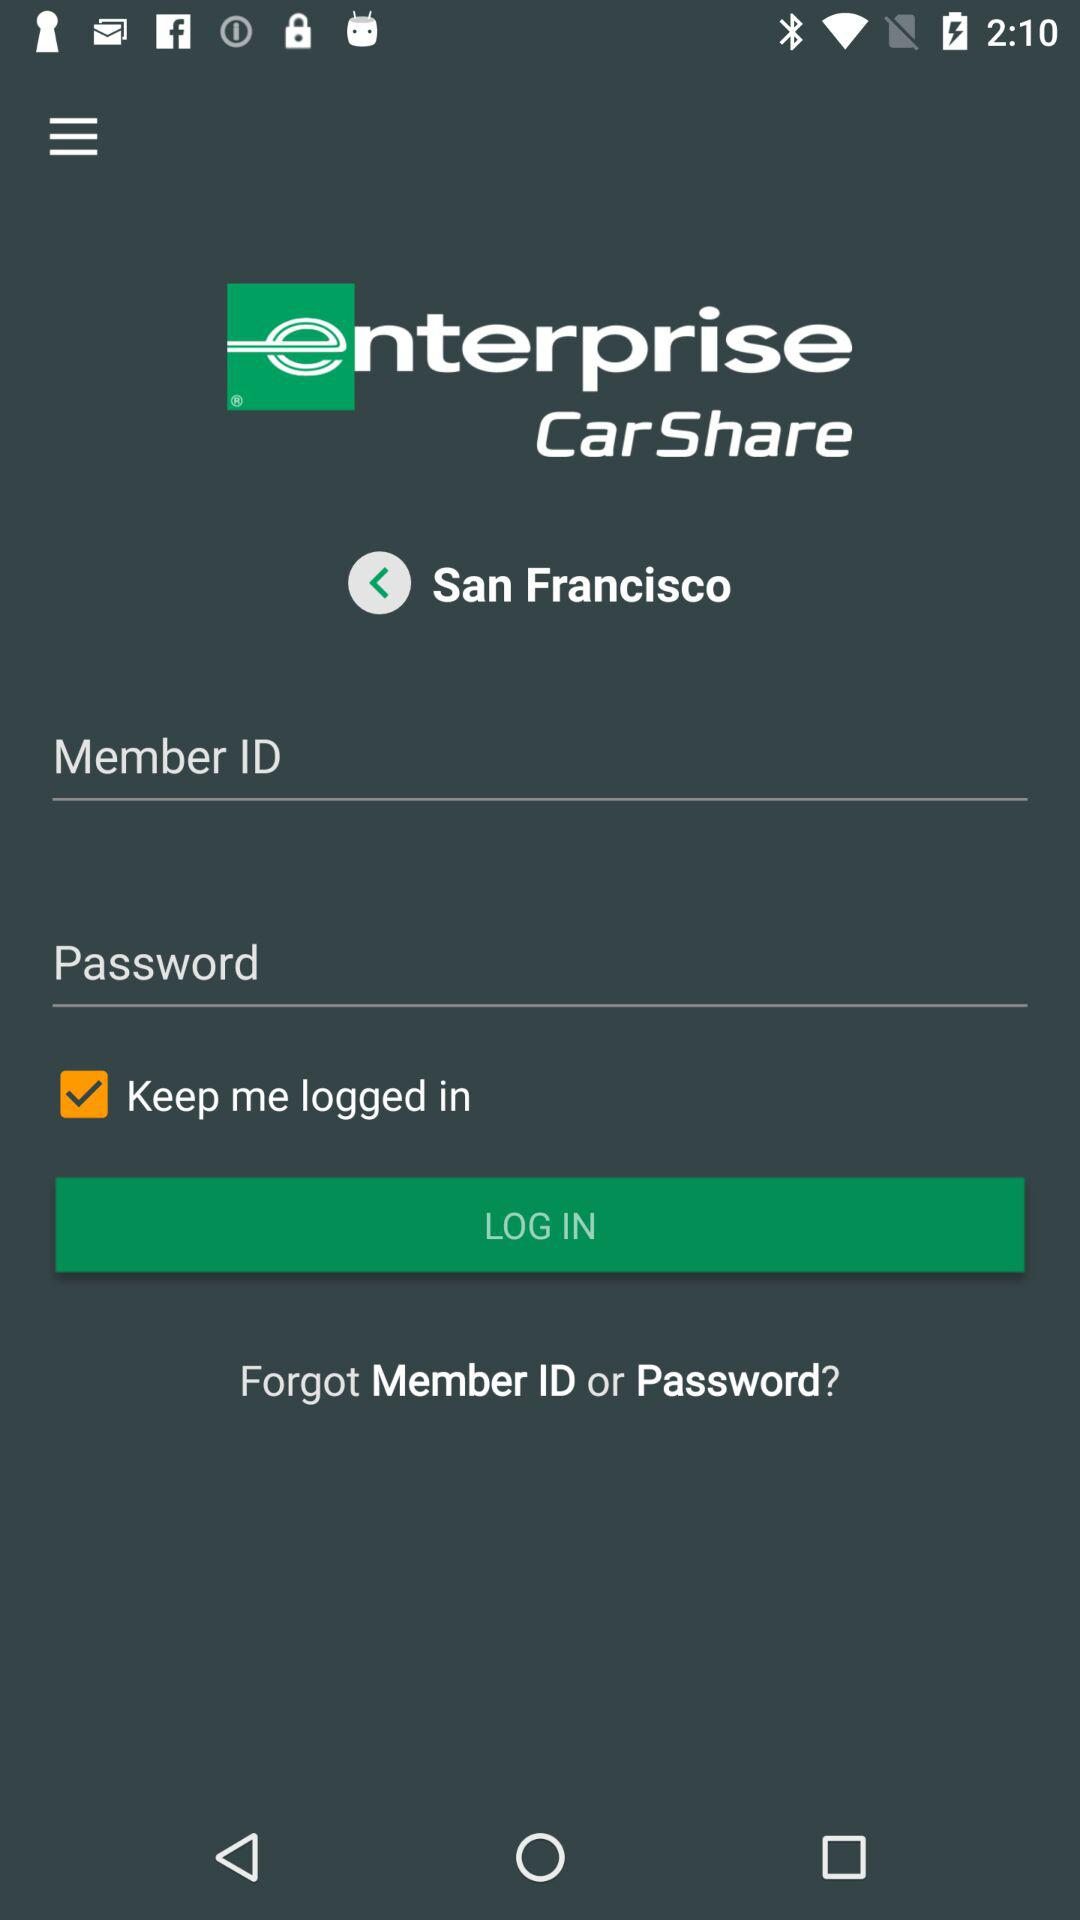How many check boxes are there on the screen?
Answer the question using a single word or phrase. 1 